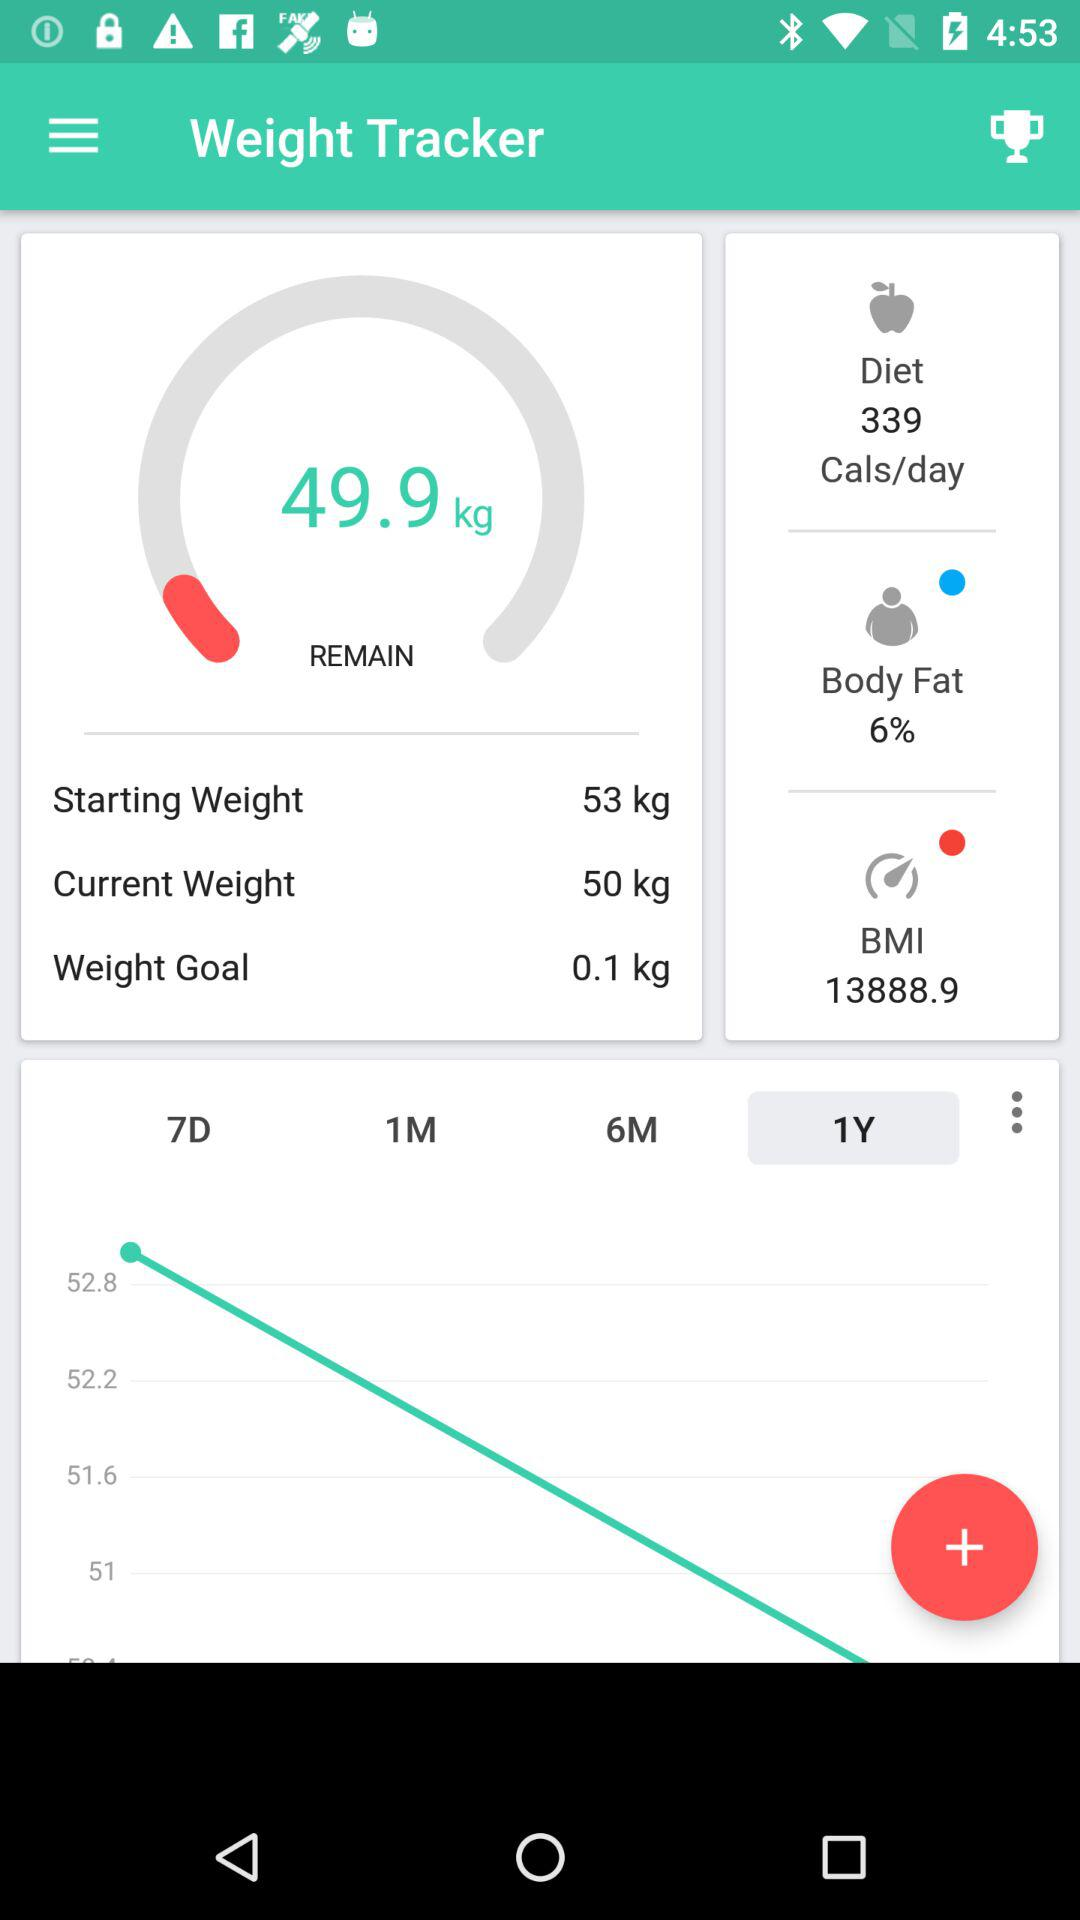How many calories are consumed in a day? The calories consumed in a day are 339. 